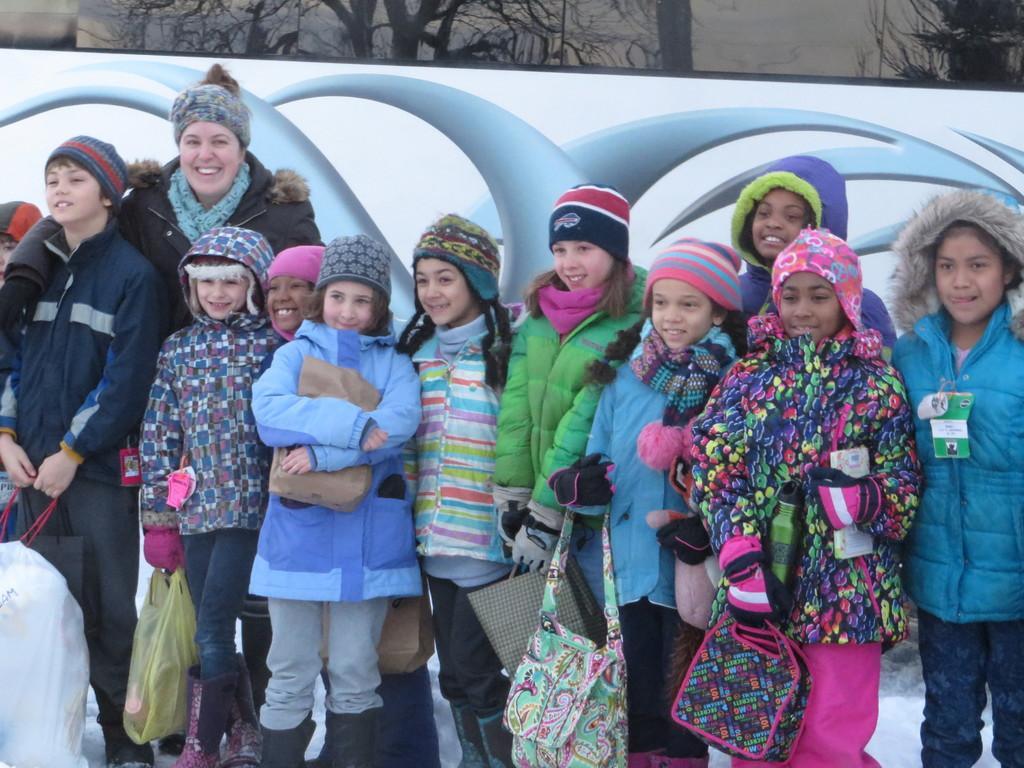Can you describe this image briefly? In this image I can see a group of girls are standing and smiling, they are wearing coats and caps. 